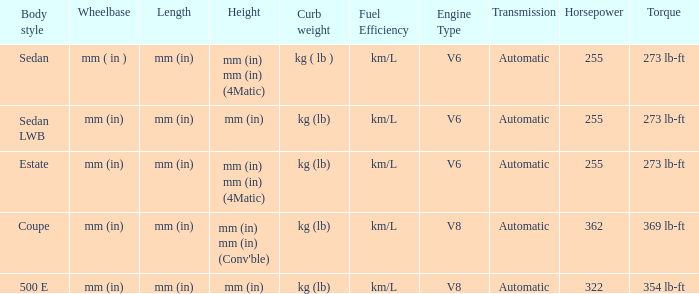What's the length of the model with 500 E body style? Mm (in). 